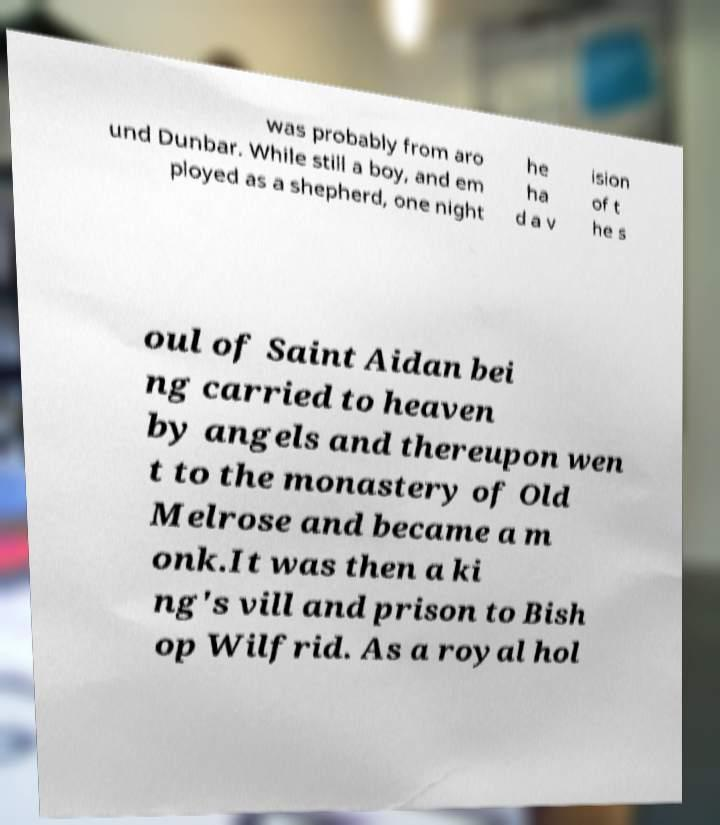Can you read and provide the text displayed in the image?This photo seems to have some interesting text. Can you extract and type it out for me? was probably from aro und Dunbar. While still a boy, and em ployed as a shepherd, one night he ha d a v ision of t he s oul of Saint Aidan bei ng carried to heaven by angels and thereupon wen t to the monastery of Old Melrose and became a m onk.It was then a ki ng's vill and prison to Bish op Wilfrid. As a royal hol 